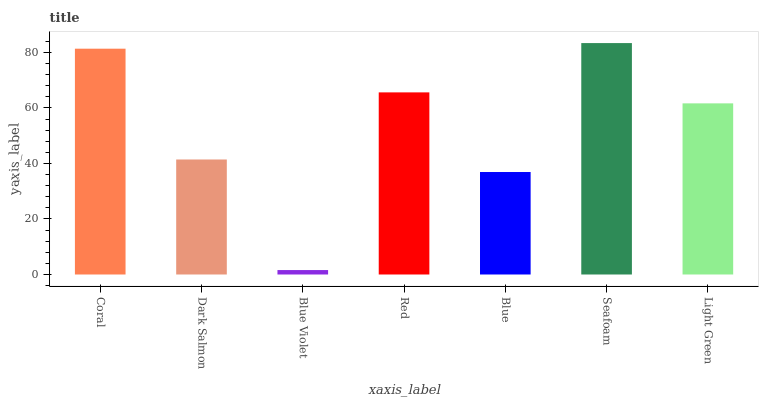Is Blue Violet the minimum?
Answer yes or no. Yes. Is Seafoam the maximum?
Answer yes or no. Yes. Is Dark Salmon the minimum?
Answer yes or no. No. Is Dark Salmon the maximum?
Answer yes or no. No. Is Coral greater than Dark Salmon?
Answer yes or no. Yes. Is Dark Salmon less than Coral?
Answer yes or no. Yes. Is Dark Salmon greater than Coral?
Answer yes or no. No. Is Coral less than Dark Salmon?
Answer yes or no. No. Is Light Green the high median?
Answer yes or no. Yes. Is Light Green the low median?
Answer yes or no. Yes. Is Seafoam the high median?
Answer yes or no. No. Is Red the low median?
Answer yes or no. No. 